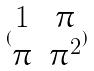Convert formula to latex. <formula><loc_0><loc_0><loc_500><loc_500>( \begin{matrix} 1 & \pi \\ \pi & \pi ^ { 2 } \end{matrix} )</formula> 